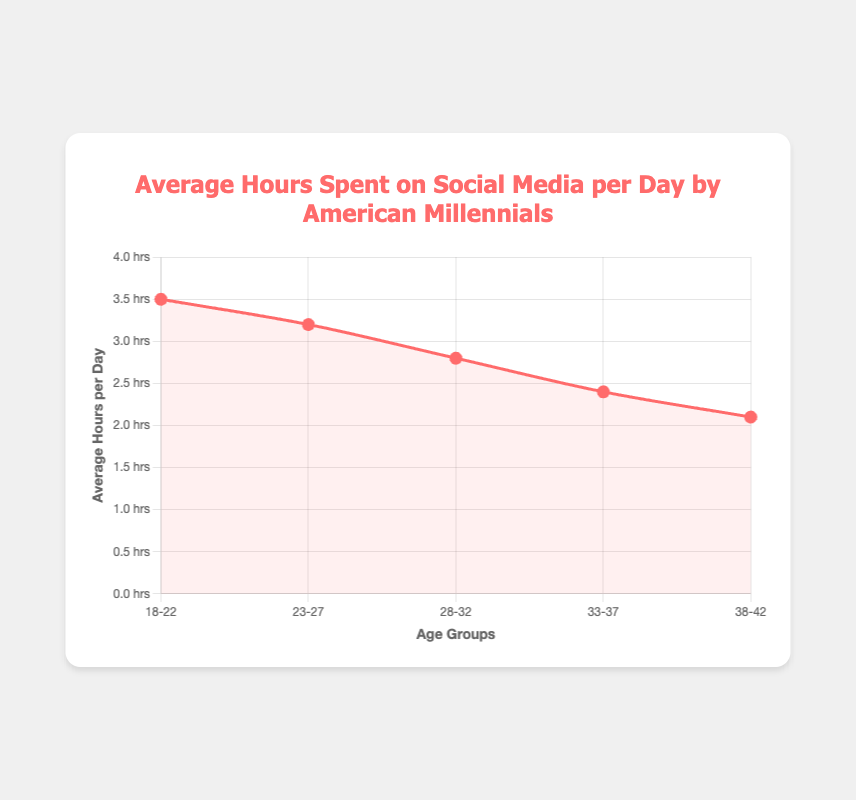Which age group spends the most time on social media per day on average? The figure shows the average hours spent per day for each age group. The highest value is for the 18-22 age group at 3.5 hours.
Answer: 18-22 Which two age groups have the smallest difference in average hours spent per day on social media? The differences between consecutive age groups are: 18-22 and 23-27 (0.3 hours), 23-27 and 28-32 (0.4 hours), 28-32 and 33-37 (0.4 hours), 33-37 and 38-42 (0.3 hours). The smallest difference is 0.3 hours, occurring between 18-22 and 23-27, and between 33-37 and 38-42.
Answer: 18-22 and 23-27, 33-37 and 38-42 What is the average of the average hours spent on social media per day for all age groups combined? The average is calculated by summing all the average hours and dividing by the number of age groups: (3.5 + 3.2 + 2.8 + 2.4 + 2.1) / 5 = 14 / 5 = 2.8 hours.
Answer: 2.8 By how much does the average social media usage decrease from the age group 18-22 to 38-42? The decrease is calculated as 3.5 hours (18-22) minus 2.1 hours (38-42), which equals 1.4 hours.
Answer: 1.4 Which age group has an average social media usage closest to 3 hours per day? The average hours spent for the 23-27 age group is 3.2, which is closest to 3 hours.
Answer: 23-27 What is the median value of the average hours spent per day on social media among the age groups? The median is the middle value when the numbers are ordered. Ordered values: 2.1, 2.4, 2.8, 3.2, 3.5. The middle value is 2.8.
Answer: 2.8 Which age group has the biggest drop in average hours spent per day compared to the previous age group? Compare the differences: 
18-22 to 23-27: 3.5 - 3.2 = 0.3 
23-27 to 28-32: 3.2 - 2.8 = 0.4 
28-32 to 33-37: 2.8 - 2.4 = 0.4 
33-37 to 38-42: 2.4 - 2.1 = 0.3 
The biggest drop is between 23-27 and 28-32, and between 28-32 and 33-37, both decreasing by 0.4 hours.
Answer: 23-27 to 28-32, 28-32 to 33-37 